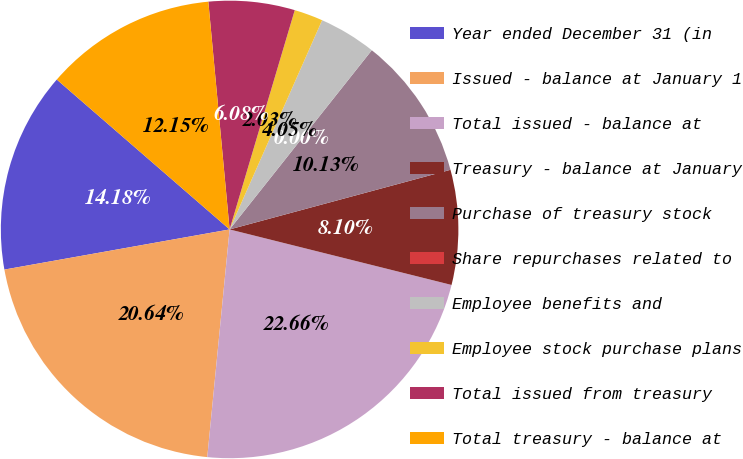<chart> <loc_0><loc_0><loc_500><loc_500><pie_chart><fcel>Year ended December 31 (in<fcel>Issued - balance at January 1<fcel>Total issued - balance at<fcel>Treasury - balance at January<fcel>Purchase of treasury stock<fcel>Share repurchases related to<fcel>Employee benefits and<fcel>Employee stock purchase plans<fcel>Total issued from treasury<fcel>Total treasury - balance at<nl><fcel>14.18%<fcel>20.64%<fcel>22.66%<fcel>8.1%<fcel>10.13%<fcel>0.0%<fcel>4.05%<fcel>2.03%<fcel>6.08%<fcel>12.15%<nl></chart> 